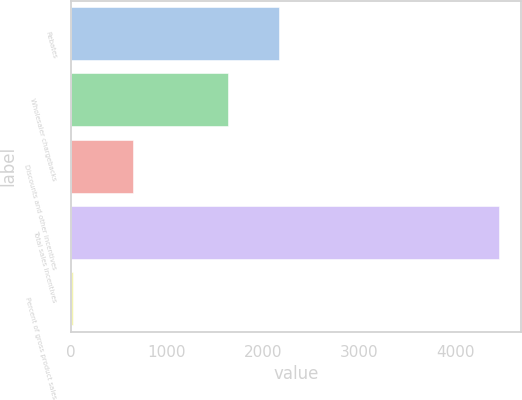Convert chart to OTSL. <chart><loc_0><loc_0><loc_500><loc_500><bar_chart><fcel>Rebates<fcel>Wholesaler chargebacks<fcel>Discounts and other incentives<fcel>Total sales incentives<fcel>Percent of gross product sales<nl><fcel>2164<fcel>1636<fcel>653<fcel>4453<fcel>24<nl></chart> 